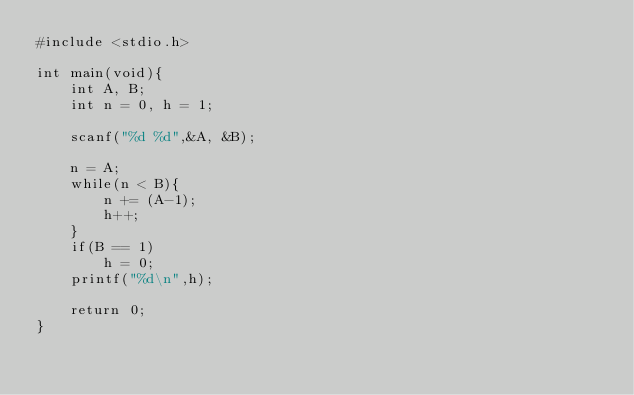<code> <loc_0><loc_0><loc_500><loc_500><_C_>#include <stdio.h>

int main(void){
    int A, B;
    int n = 0, h = 1;

    scanf("%d %d",&A, &B);

    n = A;
    while(n < B){
        n += (A-1);
        h++;
    }
    if(B == 1)
        h = 0;
    printf("%d\n",h);

    return 0;
}
</code> 